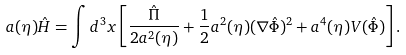<formula> <loc_0><loc_0><loc_500><loc_500>a ( \eta ) \hat { H } = \int d ^ { 3 } x \left [ \frac { \hat { \Pi } } { 2 a ^ { 2 } ( \eta ) } + \frac { 1 } { 2 } a ^ { 2 } ( \eta ) ( \nabla \hat { \Phi } ) ^ { 2 } + a ^ { 4 } ( \eta ) V ( \hat { \Phi } ) \right ] .</formula> 